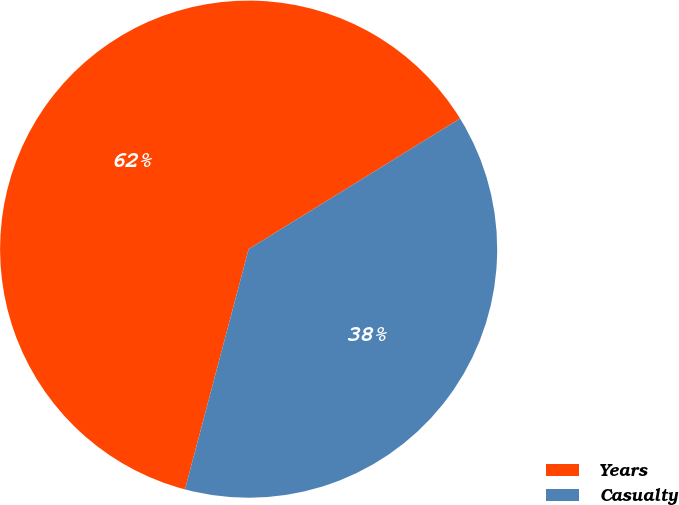Convert chart to OTSL. <chart><loc_0><loc_0><loc_500><loc_500><pie_chart><fcel>Years<fcel>Casualty<nl><fcel>62.07%<fcel>37.93%<nl></chart> 